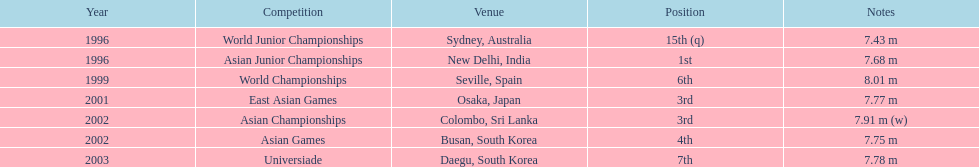In which sole contest did this competitor attain the top rank? Asian Junior Championships. Can you give me this table as a dict? {'header': ['Year', 'Competition', 'Venue', 'Position', 'Notes'], 'rows': [['1996', 'World Junior Championships', 'Sydney, Australia', '15th (q)', '7.43 m'], ['1996', 'Asian Junior Championships', 'New Delhi, India', '1st', '7.68 m'], ['1999', 'World Championships', 'Seville, Spain', '6th', '8.01 m'], ['2001', 'East Asian Games', 'Osaka, Japan', '3rd', '7.77 m'], ['2002', 'Asian Championships', 'Colombo, Sri Lanka', '3rd', '7.91 m (w)'], ['2002', 'Asian Games', 'Busan, South Korea', '4th', '7.75 m'], ['2003', 'Universiade', 'Daegu, South Korea', '7th', '7.78 m']]} 